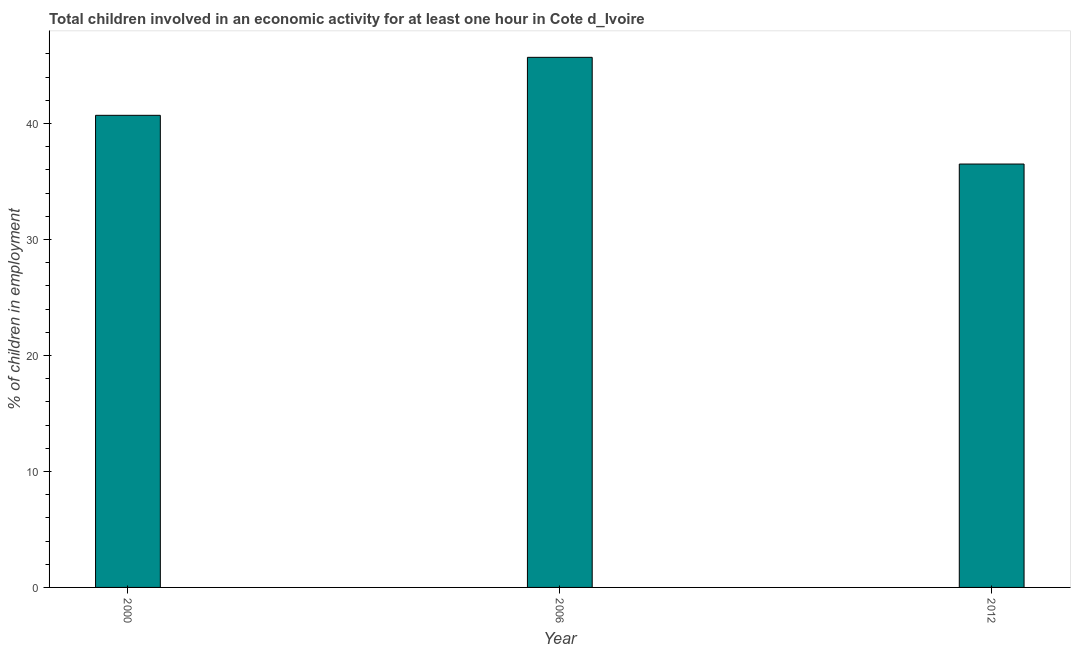Does the graph contain any zero values?
Provide a succinct answer. No. Does the graph contain grids?
Offer a very short reply. No. What is the title of the graph?
Provide a succinct answer. Total children involved in an economic activity for at least one hour in Cote d_Ivoire. What is the label or title of the Y-axis?
Your response must be concise. % of children in employment. What is the percentage of children in employment in 2006?
Your answer should be compact. 45.7. Across all years, what is the maximum percentage of children in employment?
Offer a terse response. 45.7. Across all years, what is the minimum percentage of children in employment?
Ensure brevity in your answer.  36.5. In which year was the percentage of children in employment maximum?
Provide a succinct answer. 2006. In which year was the percentage of children in employment minimum?
Give a very brief answer. 2012. What is the sum of the percentage of children in employment?
Offer a terse response. 122.9. What is the difference between the percentage of children in employment in 2006 and 2012?
Provide a short and direct response. 9.2. What is the average percentage of children in employment per year?
Make the answer very short. 40.97. What is the median percentage of children in employment?
Your answer should be very brief. 40.7. What is the ratio of the percentage of children in employment in 2006 to that in 2012?
Offer a very short reply. 1.25. Is the difference between the percentage of children in employment in 2000 and 2006 greater than the difference between any two years?
Ensure brevity in your answer.  No. What is the difference between the highest and the second highest percentage of children in employment?
Your answer should be very brief. 5. What is the difference between the highest and the lowest percentage of children in employment?
Keep it short and to the point. 9.2. How many bars are there?
Your answer should be very brief. 3. How many years are there in the graph?
Provide a succinct answer. 3. What is the difference between two consecutive major ticks on the Y-axis?
Your answer should be very brief. 10. Are the values on the major ticks of Y-axis written in scientific E-notation?
Keep it short and to the point. No. What is the % of children in employment in 2000?
Give a very brief answer. 40.7. What is the % of children in employment in 2006?
Provide a succinct answer. 45.7. What is the % of children in employment of 2012?
Give a very brief answer. 36.5. What is the difference between the % of children in employment in 2000 and 2012?
Keep it short and to the point. 4.2. What is the difference between the % of children in employment in 2006 and 2012?
Ensure brevity in your answer.  9.2. What is the ratio of the % of children in employment in 2000 to that in 2006?
Your answer should be very brief. 0.89. What is the ratio of the % of children in employment in 2000 to that in 2012?
Provide a short and direct response. 1.11. What is the ratio of the % of children in employment in 2006 to that in 2012?
Your response must be concise. 1.25. 